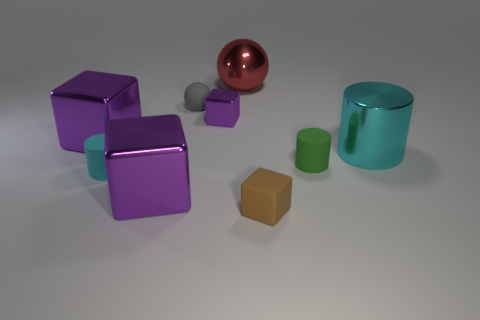Can you describe the lighting setup used in this image? The objects in the image are lit uniformly suggesting a soft, diffused light source. The shadows are soft-edged, which often results from using a large light source or a light tent, indicative of studio lighting conditions. There is no harsh direct lighting or strong specular reflections that would suggest a pinpoint light source. 